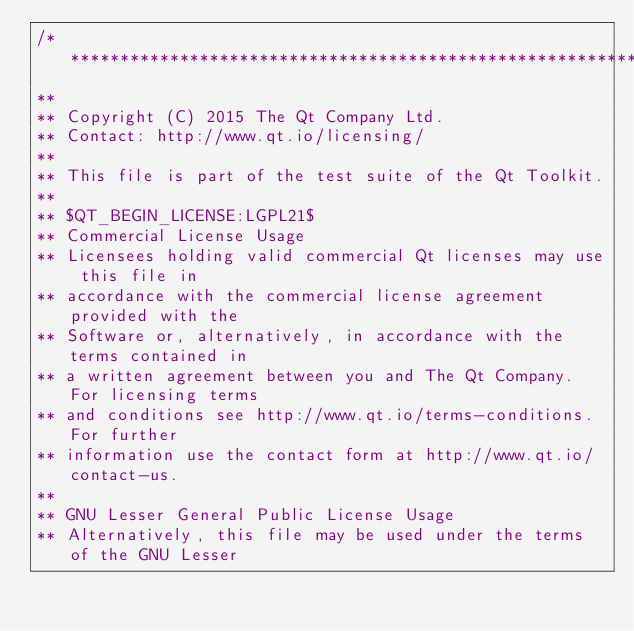Convert code to text. <code><loc_0><loc_0><loc_500><loc_500><_C++_>/****************************************************************************
**
** Copyright (C) 2015 The Qt Company Ltd.
** Contact: http://www.qt.io/licensing/
**
** This file is part of the test suite of the Qt Toolkit.
**
** $QT_BEGIN_LICENSE:LGPL21$
** Commercial License Usage
** Licensees holding valid commercial Qt licenses may use this file in
** accordance with the commercial license agreement provided with the
** Software or, alternatively, in accordance with the terms contained in
** a written agreement between you and The Qt Company. For licensing terms
** and conditions see http://www.qt.io/terms-conditions. For further
** information use the contact form at http://www.qt.io/contact-us.
**
** GNU Lesser General Public License Usage
** Alternatively, this file may be used under the terms of the GNU Lesser</code> 